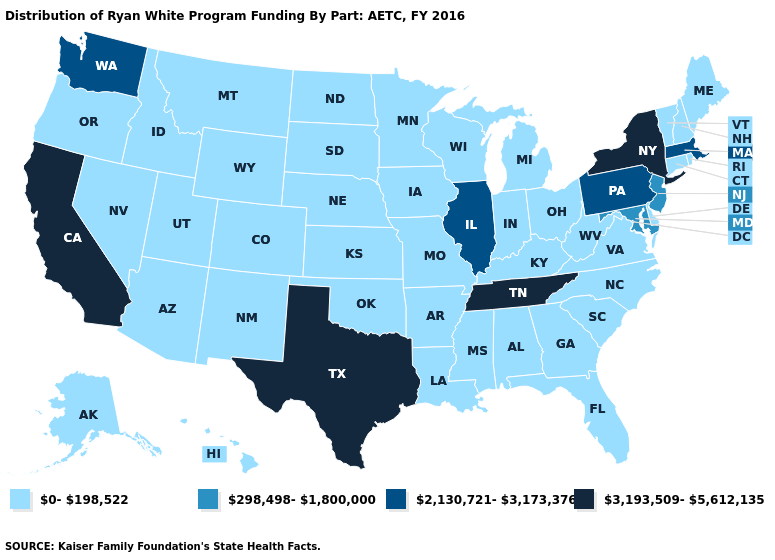Name the states that have a value in the range 0-198,522?
Keep it brief. Alabama, Alaska, Arizona, Arkansas, Colorado, Connecticut, Delaware, Florida, Georgia, Hawaii, Idaho, Indiana, Iowa, Kansas, Kentucky, Louisiana, Maine, Michigan, Minnesota, Mississippi, Missouri, Montana, Nebraska, Nevada, New Hampshire, New Mexico, North Carolina, North Dakota, Ohio, Oklahoma, Oregon, Rhode Island, South Carolina, South Dakota, Utah, Vermont, Virginia, West Virginia, Wisconsin, Wyoming. What is the lowest value in the USA?
Quick response, please. 0-198,522. Does Kansas have a lower value than Pennsylvania?
Write a very short answer. Yes. What is the value of Wyoming?
Be succinct. 0-198,522. Which states have the lowest value in the USA?
Quick response, please. Alabama, Alaska, Arizona, Arkansas, Colorado, Connecticut, Delaware, Florida, Georgia, Hawaii, Idaho, Indiana, Iowa, Kansas, Kentucky, Louisiana, Maine, Michigan, Minnesota, Mississippi, Missouri, Montana, Nebraska, Nevada, New Hampshire, New Mexico, North Carolina, North Dakota, Ohio, Oklahoma, Oregon, Rhode Island, South Carolina, South Dakota, Utah, Vermont, Virginia, West Virginia, Wisconsin, Wyoming. Which states have the highest value in the USA?
Keep it brief. California, New York, Tennessee, Texas. Name the states that have a value in the range 0-198,522?
Keep it brief. Alabama, Alaska, Arizona, Arkansas, Colorado, Connecticut, Delaware, Florida, Georgia, Hawaii, Idaho, Indiana, Iowa, Kansas, Kentucky, Louisiana, Maine, Michigan, Minnesota, Mississippi, Missouri, Montana, Nebraska, Nevada, New Hampshire, New Mexico, North Carolina, North Dakota, Ohio, Oklahoma, Oregon, Rhode Island, South Carolina, South Dakota, Utah, Vermont, Virginia, West Virginia, Wisconsin, Wyoming. What is the value of Ohio?
Quick response, please. 0-198,522. Name the states that have a value in the range 2,130,721-3,173,376?
Give a very brief answer. Illinois, Massachusetts, Pennsylvania, Washington. What is the value of Mississippi?
Answer briefly. 0-198,522. What is the lowest value in the USA?
Short answer required. 0-198,522. Is the legend a continuous bar?
Keep it brief. No. Name the states that have a value in the range 2,130,721-3,173,376?
Keep it brief. Illinois, Massachusetts, Pennsylvania, Washington. Among the states that border Wisconsin , which have the highest value?
Quick response, please. Illinois. 